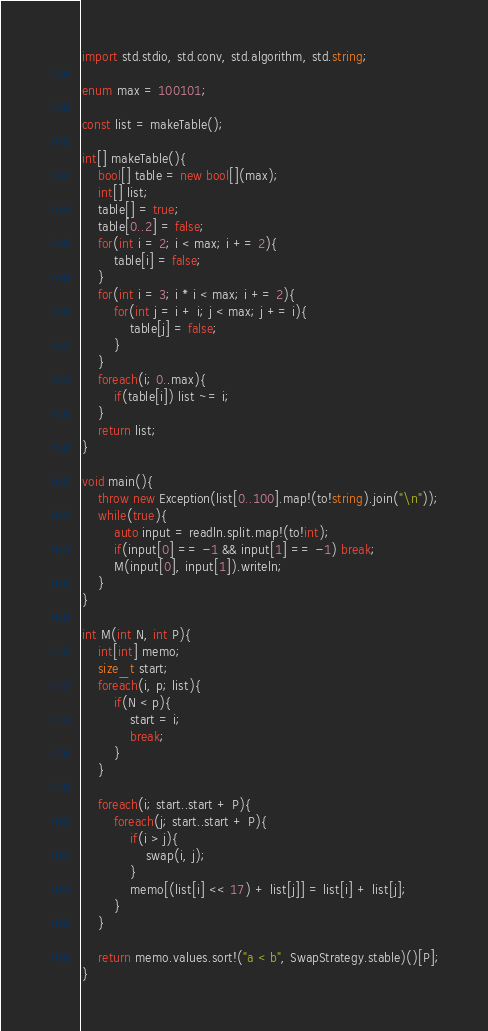Convert code to text. <code><loc_0><loc_0><loc_500><loc_500><_D_>import std.stdio, std.conv, std.algorithm, std.string;

enum max = 100101;

const list = makeTable();

int[] makeTable(){
    bool[] table = new bool[](max);
    int[] list;
    table[] = true;
    table[0..2] = false;
    for(int i = 2; i < max; i += 2){
        table[i] = false;
    }
    for(int i = 3; i * i < max; i += 2){
        for(int j = i + i; j < max; j += i){
            table[j] = false;
        }
    }
    foreach(i; 0..max){
        if(table[i]) list ~= i;
    }
    return list;
}

void main(){
    throw new Exception(list[0..100].map!(to!string).join("\n"));
    while(true){
        auto input = readln.split.map!(to!int);
        if(input[0] == -1 && input[1] == -1) break;
        M(input[0], input[1]).writeln;
    }
}

int M(int N, int P){
    int[int] memo;
    size_t start;
    foreach(i, p; list){
        if(N < p){
            start = i;
            break;
        }
    }

    foreach(i; start..start + P){
        foreach(j; start..start + P){
            if(i > j){
                swap(i, j);
            }
            memo[(list[i] << 17) + list[j]] = list[i] + list[j];
        }
    }

    return memo.values.sort!("a < b", SwapStrategy.stable)()[P];
}</code> 